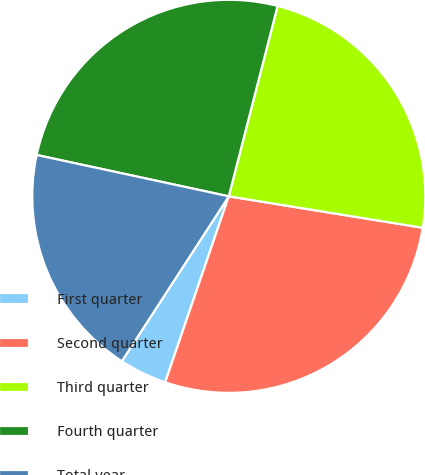<chart> <loc_0><loc_0><loc_500><loc_500><pie_chart><fcel>First quarter<fcel>Second quarter<fcel>Third quarter<fcel>Fourth quarter<fcel>Total year<nl><fcel>3.91%<fcel>27.69%<fcel>23.56%<fcel>25.62%<fcel>19.22%<nl></chart> 